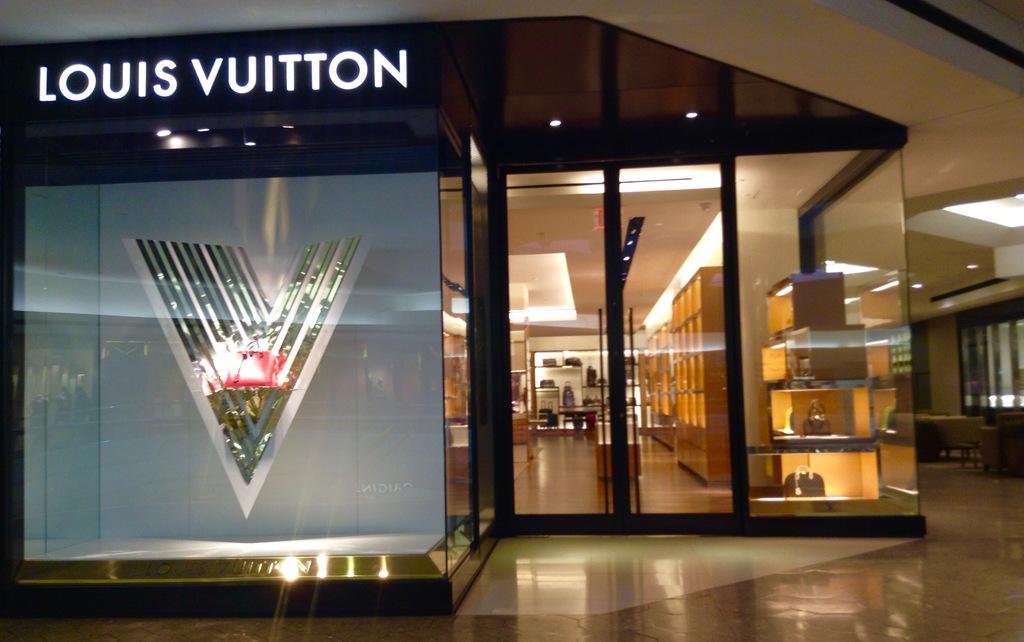What is the name of the store?
Your answer should be very brief. Louis vuitton. What do they sell at the store?
Keep it short and to the point. Unanswerable. 